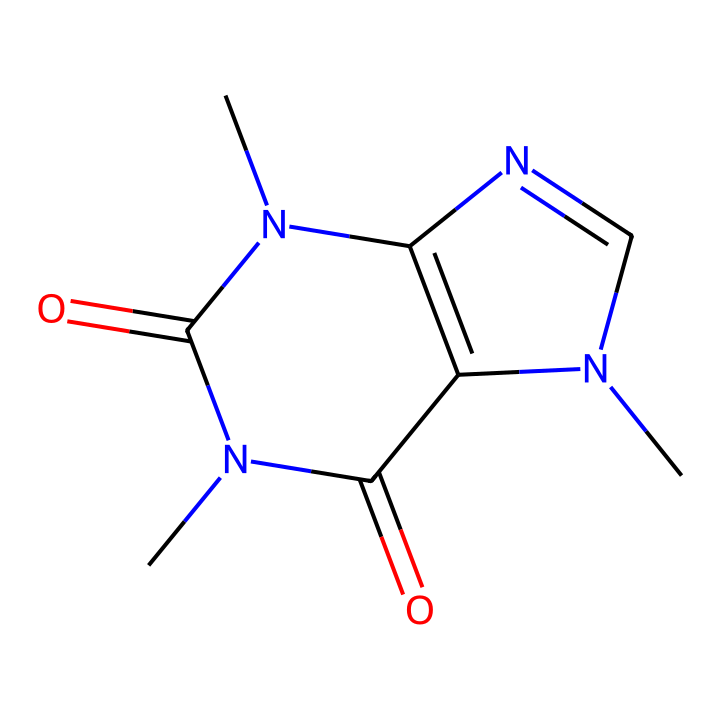What is the molecular formula of caffeine? To find the molecular formula, we need to count the carbon (C), hydrogen (H), nitrogen (N), and oxygen (O) atoms present in the SMILES representation. The breaking down of the structure shows there are 8 carbon atoms, 10 hydrogen atoms, 4 nitrogen atoms, and 2 oxygen atoms, leading to the formula C8H10N4O2.
Answer: C8H10N4O2 How many rings are present in the structure of caffeine? By examining the SMILES representation, we can observe that there are two numbers (1 and 2) indicating the start of ring connections. This confirms that caffeine has 2 fused ring structures (a bicyclic compound).
Answer: 2 What type of base is caffeine classified as? Given that caffeine contains nitrogen atoms in its structure and exhibits basic properties, it can be classified as an alkaloid base. Alkaloids are known for having nitrogen and exhibiting basic behavior in chemical reactions.
Answer: alkaloid How many nitrogen atoms are there in caffeine? In the SMILES notation, we identify nitrogen atoms by finding the letter "N." Counting these, we find there are 4 nitrogen atoms in total.
Answer: 4 What are the functional groups present in caffeine? A close examination of the molecular structure reveals the presence of imine (C=N) functionality as well as carbonyl groups (C=O), which are typical in caffeine's structure, confirming its functionality as an aromatic compound.
Answer: imine and carbonyl groups Is caffeine a polar or nonpolar molecule? Considering the presence of nitrogen and oxygen atoms, alongside the molecular geometry and functional groups in caffeine, it indicates a polar nature due to uneven charge distribution, especially from the electronegative atoms.
Answer: polar 